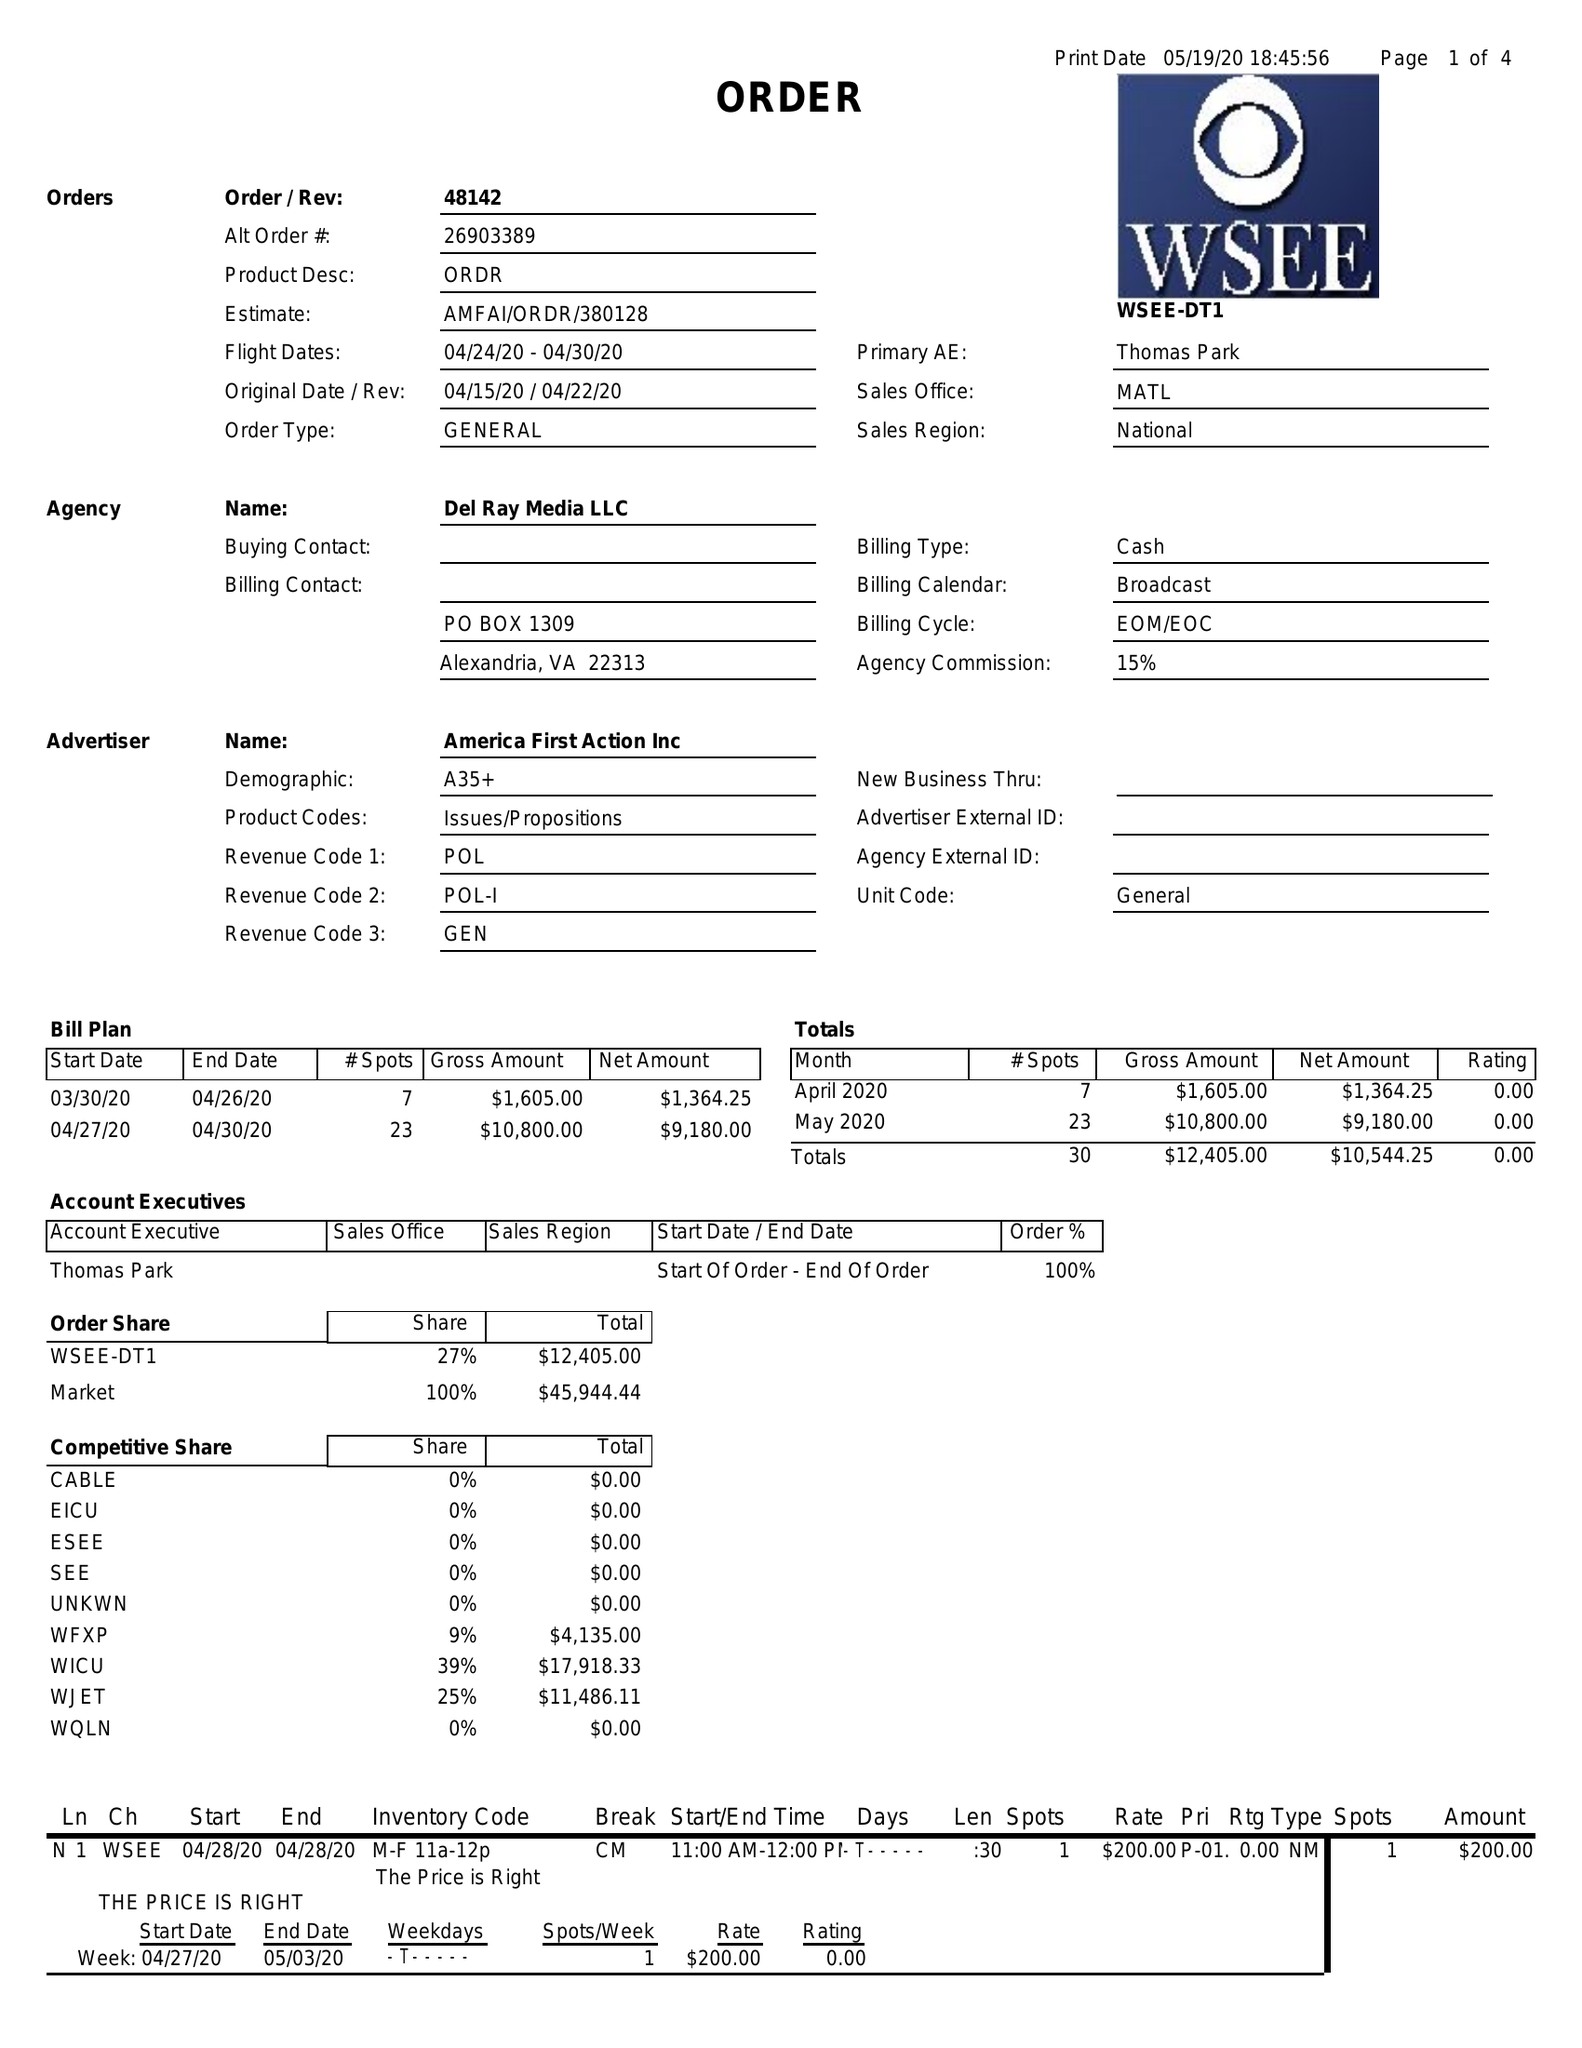What is the value for the flight_to?
Answer the question using a single word or phrase. 04/30/20 